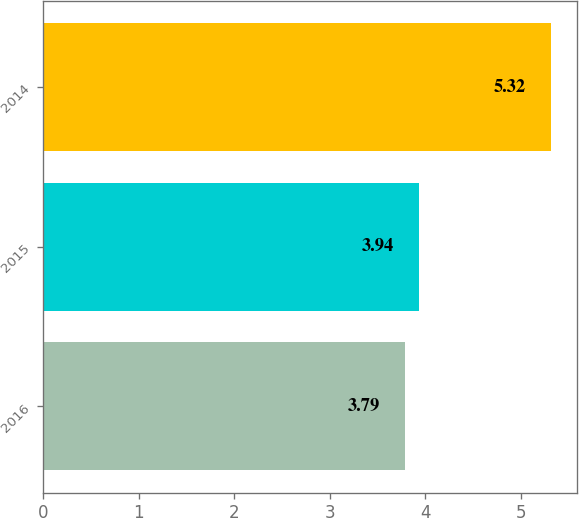<chart> <loc_0><loc_0><loc_500><loc_500><bar_chart><fcel>2016<fcel>2015<fcel>2014<nl><fcel>3.79<fcel>3.94<fcel>5.32<nl></chart> 